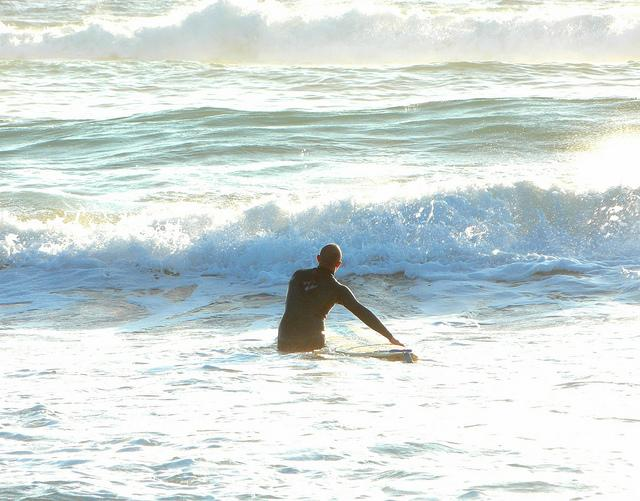World surf league is the highest governing body of which sport? surfing 